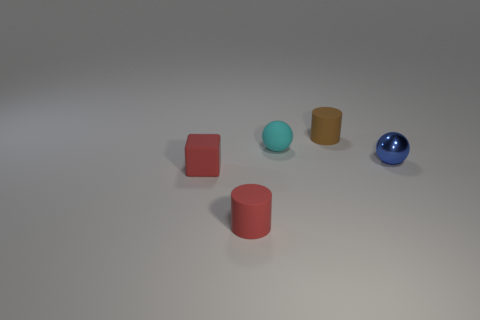How many tiny things are cyan objects or matte cylinders?
Make the answer very short. 3. Do the thing that is behind the matte sphere and the cyan rubber thing have the same size?
Provide a short and direct response. Yes. How many other things are the same color as the small rubber block?
Provide a succinct answer. 1. What is the material of the tiny block?
Your answer should be compact. Rubber. What is the material of the thing that is in front of the brown rubber thing and behind the metal object?
Provide a short and direct response. Rubber. How many things are rubber cylinders that are to the right of the small matte ball or red matte things?
Provide a short and direct response. 3. Is the metal ball the same color as the small matte ball?
Keep it short and to the point. No. Are there any cyan cubes of the same size as the shiny thing?
Your answer should be very brief. No. What number of things are both right of the tiny cyan sphere and in front of the small brown matte thing?
Offer a very short reply. 1. There is a tiny matte sphere; how many blocks are to the left of it?
Keep it short and to the point. 1. 